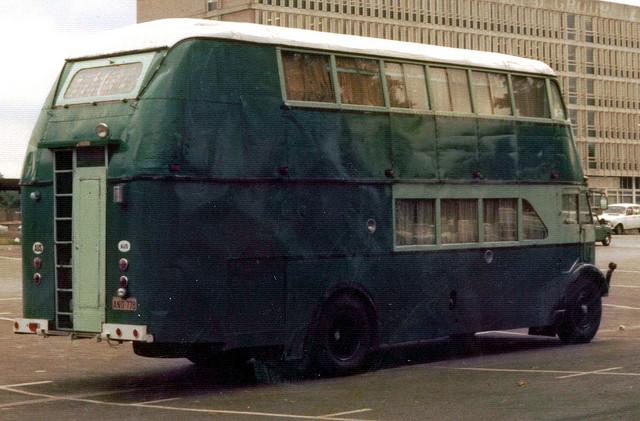How many stories is the bus?
Keep it brief. 2. How many windows are visible on the bus?
Answer briefly. 13. How many levels is the bus?
Answer briefly. 2. 